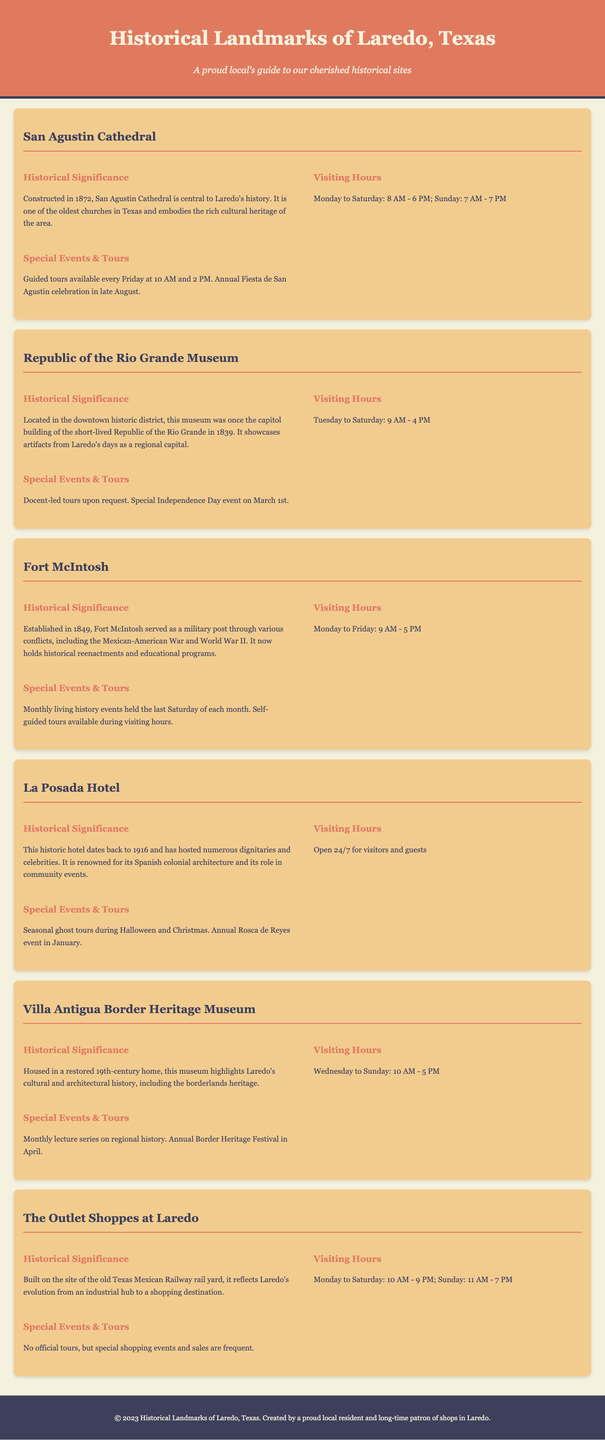What year was San Agustin Cathedral constructed? San Agustin Cathedral was constructed in the year mentioned in the document.
Answer: 1872 What are the visiting hours for the Republic of the Rio Grande Museum? The visiting hours for the Republic of the Rio Grande Museum are stated in the document.
Answer: Tuesday to Saturday: 9 AM - 4 PM What monthly event is held at Fort McIntosh? The document mentions a specific monthly event that occurs at Fort McIntosh.
Answer: Living history events What significant event occurs at La Posada Hotel during Christmas? The document states a specific event related to Christmas at La Posada Hotel.
Answer: Seasonal ghost tours On what day is the Border Heritage Festival held? The document indicates the timing of a specific festival related to border heritage.
Answer: April 